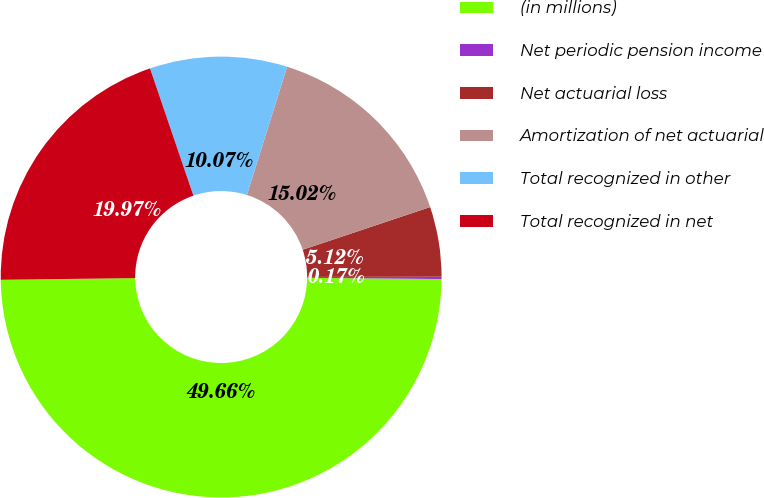Convert chart to OTSL. <chart><loc_0><loc_0><loc_500><loc_500><pie_chart><fcel>(in millions)<fcel>Net periodic pension income<fcel>Net actuarial loss<fcel>Amortization of net actuarial<fcel>Total recognized in other<fcel>Total recognized in net<nl><fcel>49.66%<fcel>0.17%<fcel>5.12%<fcel>15.02%<fcel>10.07%<fcel>19.97%<nl></chart> 